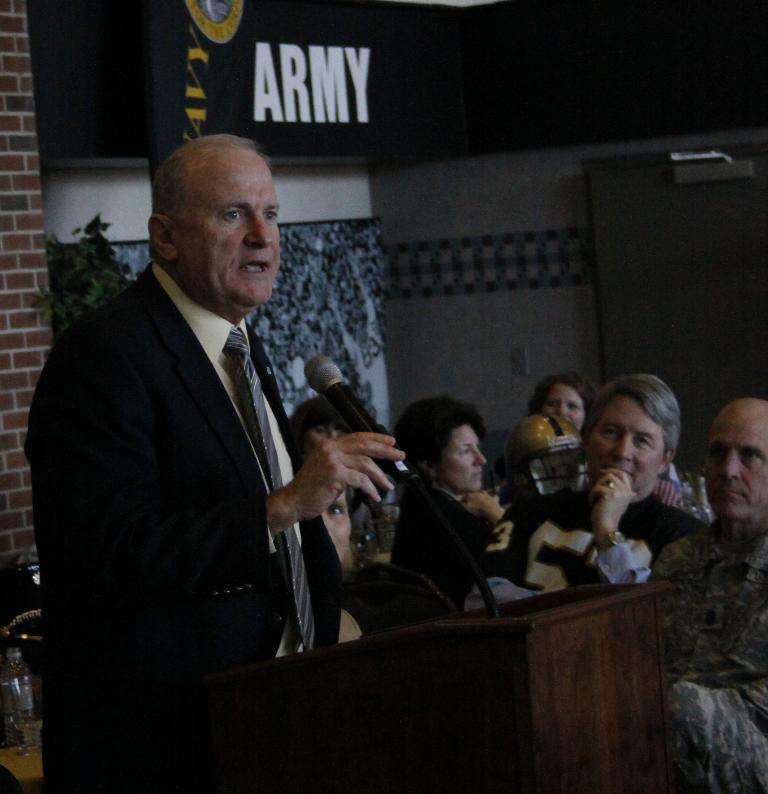Can you describe this image briefly? In this image I can see group of people sitting, in front the person is standing wearing black color blazer, cream shirt and holding a microphone, in front I can see a podium, background I can see a black color banner attached to the wall and the wall is in white color. 